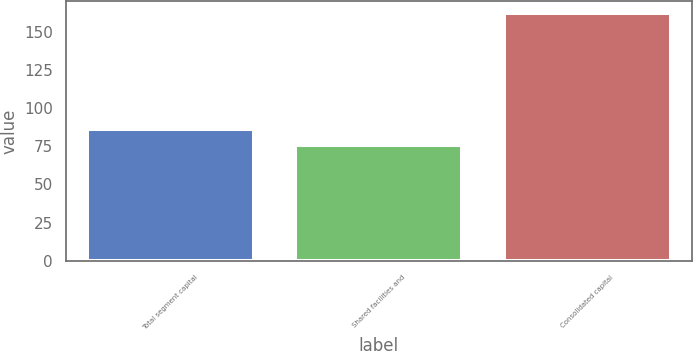Convert chart. <chart><loc_0><loc_0><loc_500><loc_500><bar_chart><fcel>Total segment capital<fcel>Shared facilities and<fcel>Consolidated capital<nl><fcel>86<fcel>76<fcel>162<nl></chart> 